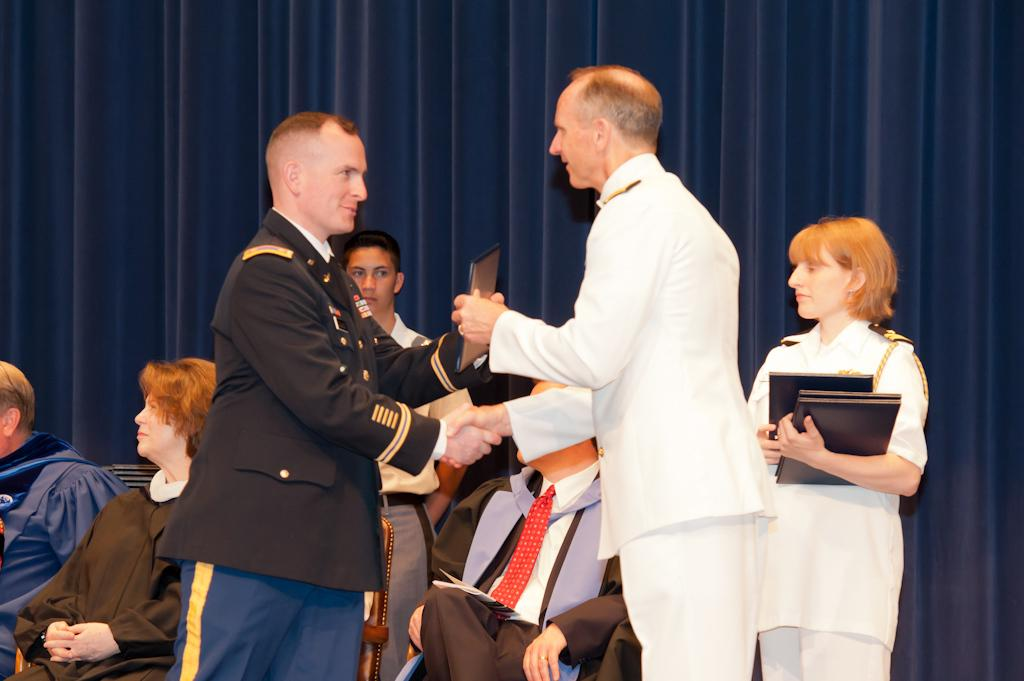What is happening on the stage in the image? There is a group of people on the stage in the image. What can be seen in the background of the stage? There is a curtain in the background of the image. Can you tell if the image was taken during the day or night? The image may have been taken during the night. What type of plastic material is being copied by the crack in the image? There is no plastic material or crack present in the image. 